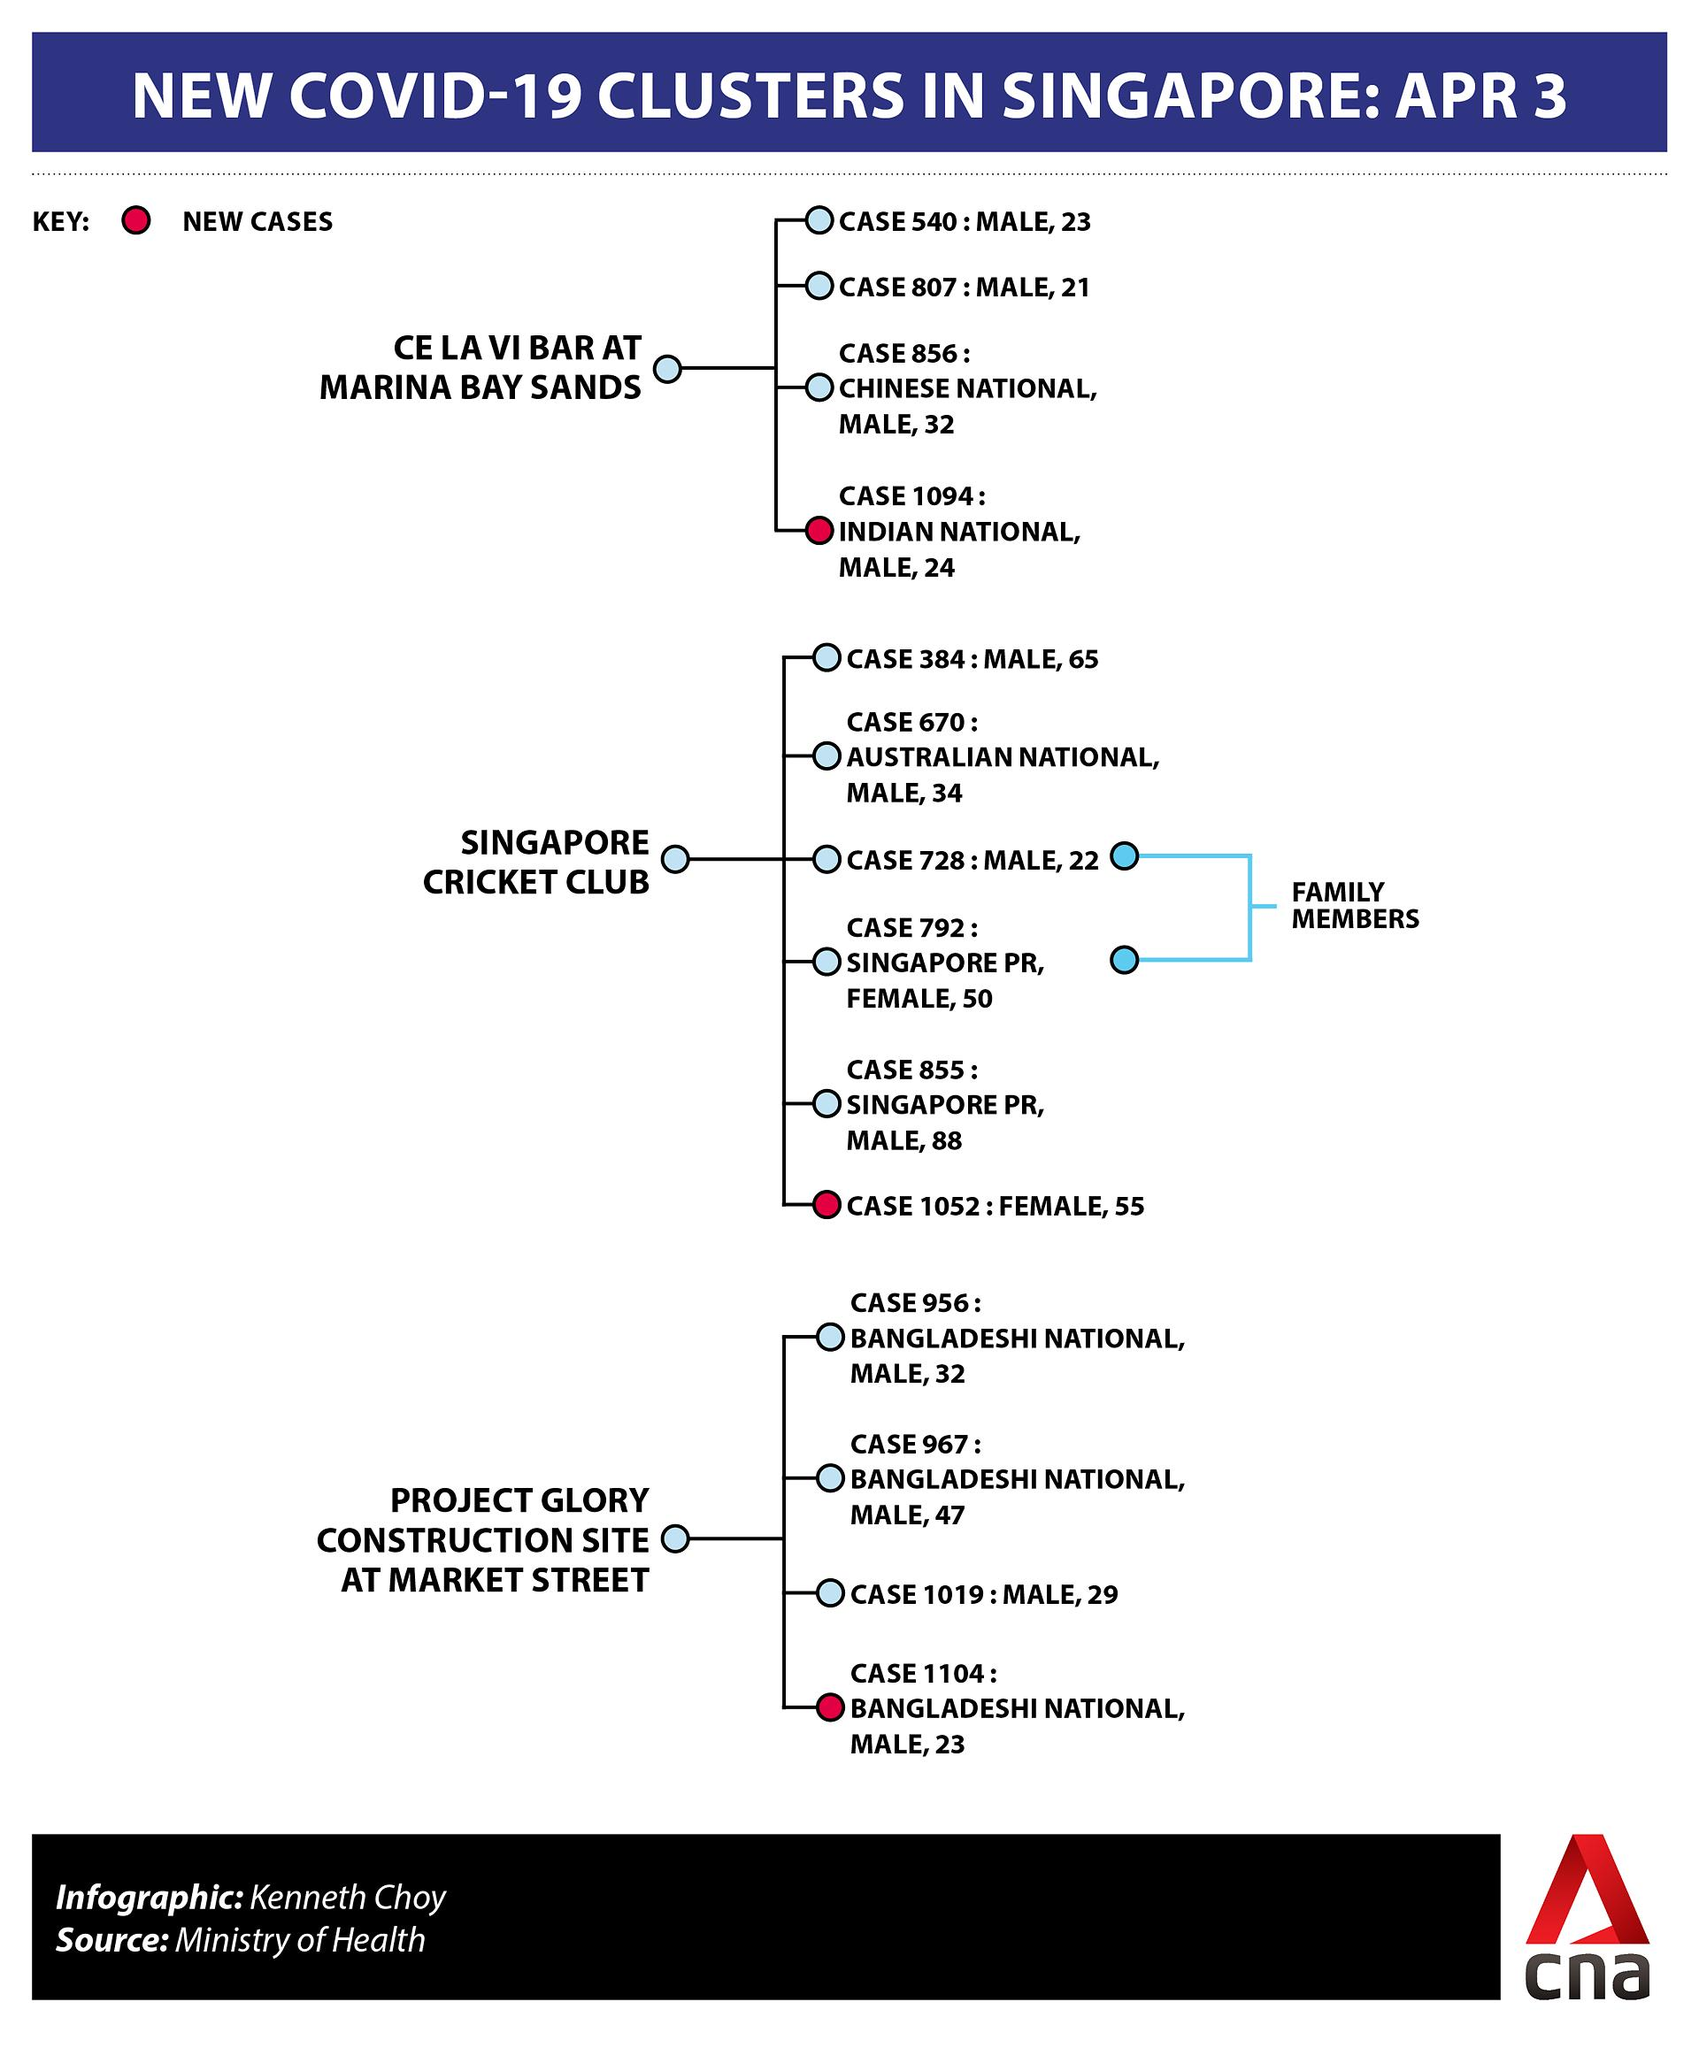Give some essential details in this illustration. There are 4 cases in the Marina Bay bands cluster. The patients who are family members are identified by case numbers, such as case 728 and case 792. There are four cases in the Market Street cluster. The gender of the new patient on Market Street is male. The case number of the new patient of Marina Bay Bands is 1094. 